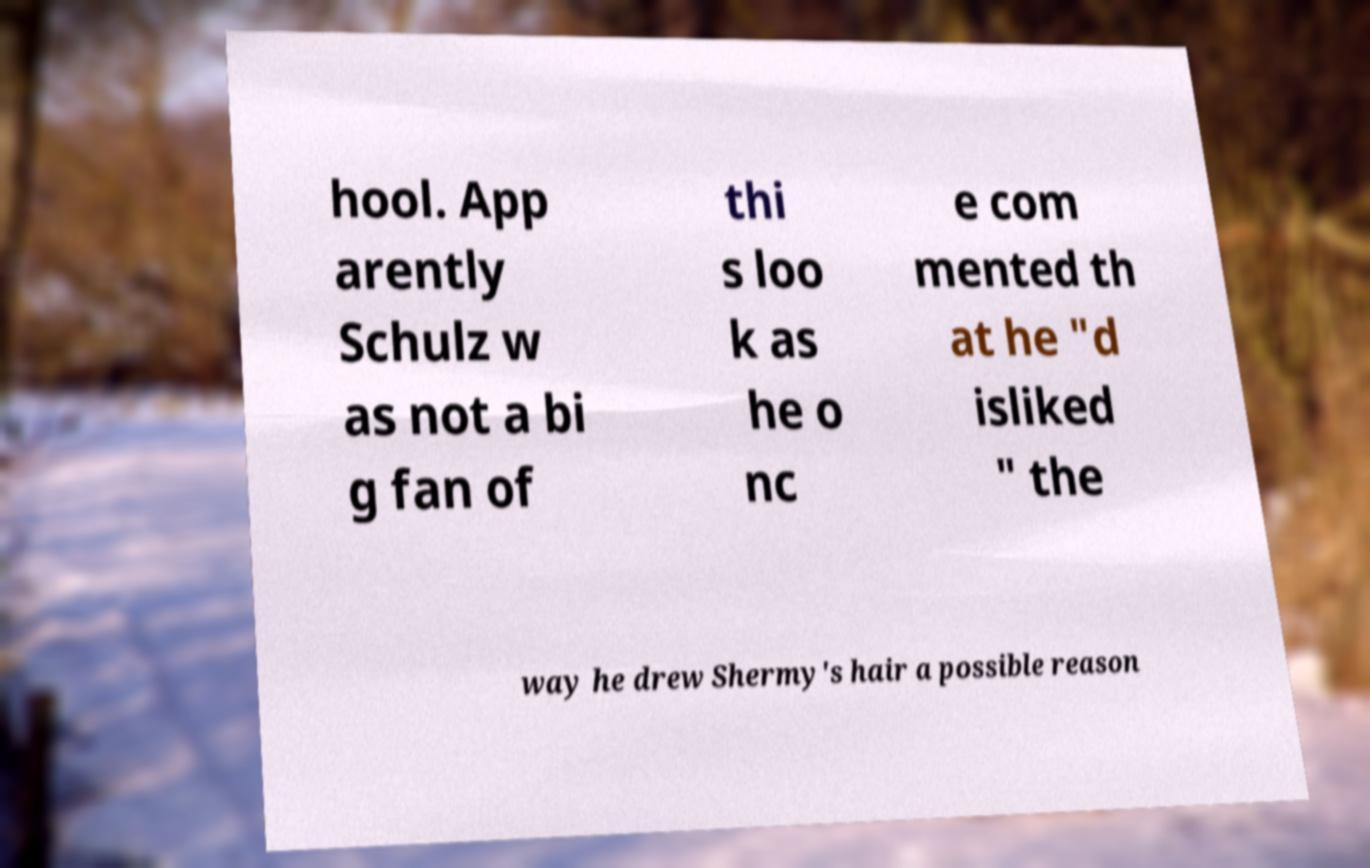For documentation purposes, I need the text within this image transcribed. Could you provide that? hool. App arently Schulz w as not a bi g fan of thi s loo k as he o nc e com mented th at he "d isliked " the way he drew Shermy's hair a possible reason 